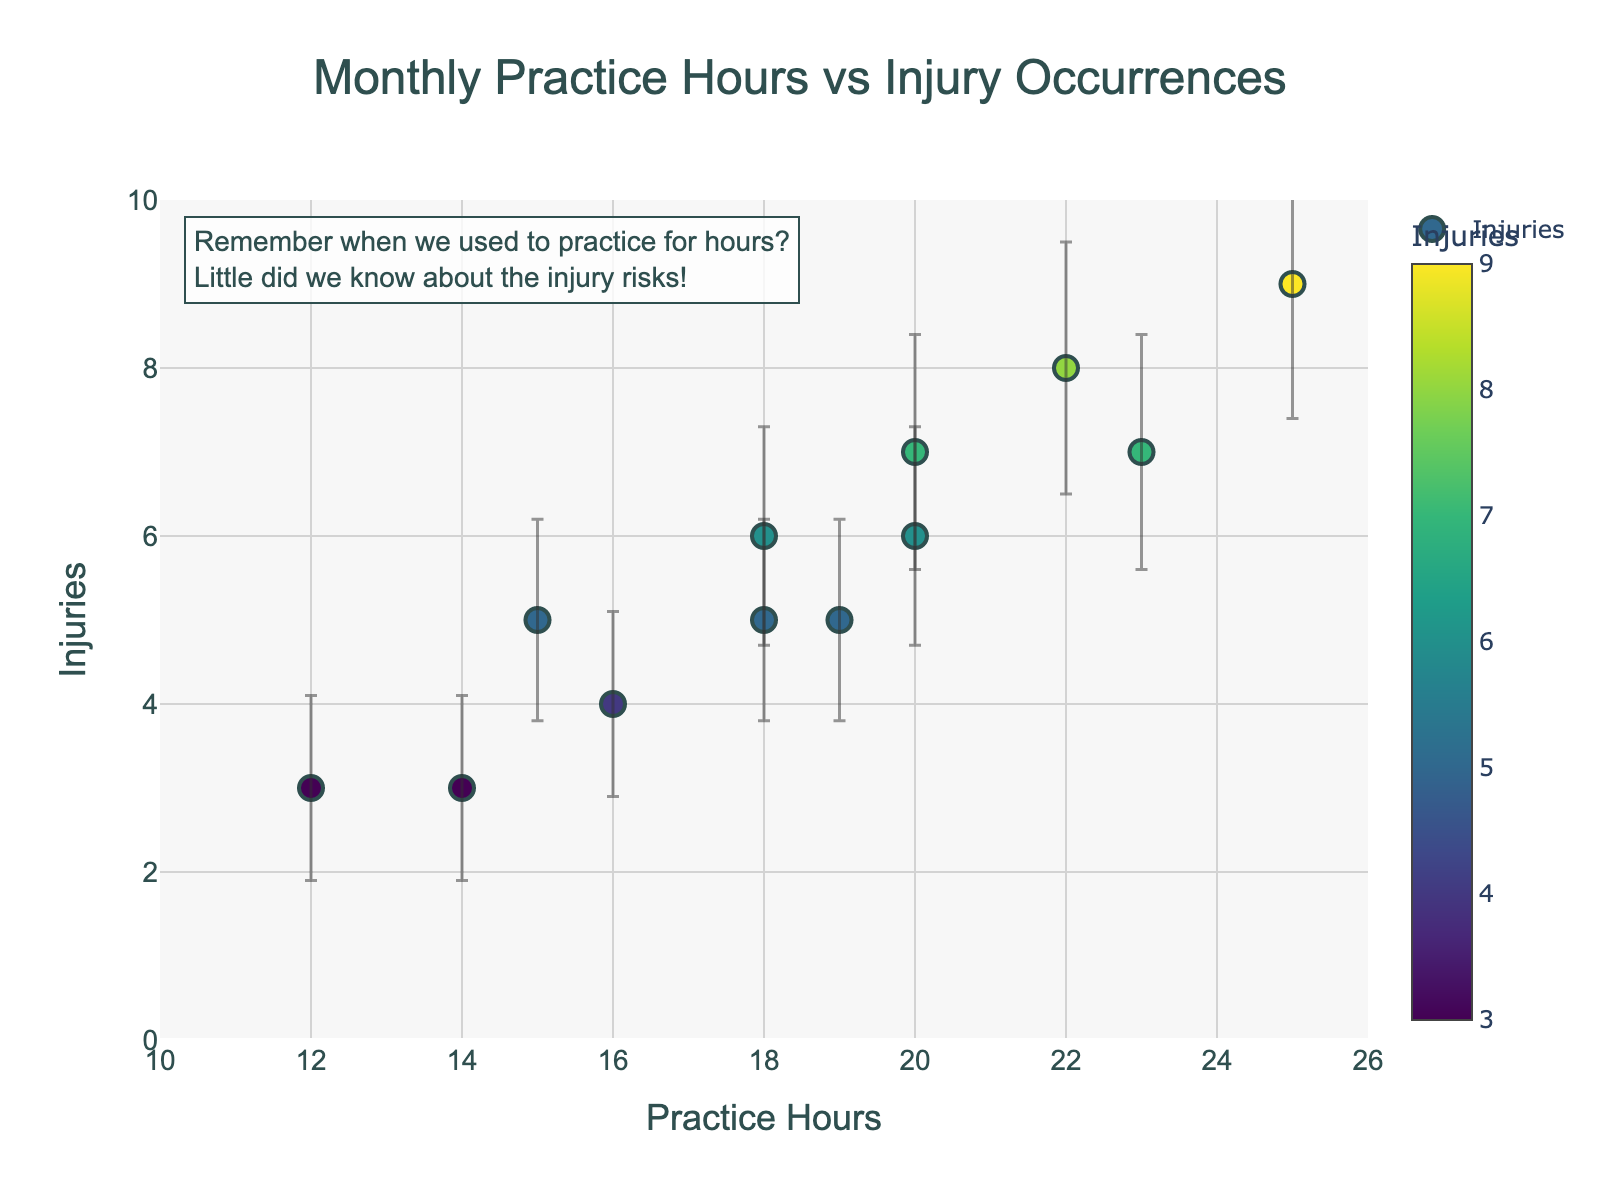What is the title of the plot? The title of the plot is located at the top center and reads "Monthly Practice Hours vs Injury Occurrences".
Answer: Monthly Practice Hours vs Injury Occurrences How many data points are there in the plot? The plot has markers for each month of the year, indicating there are 12 data points.
Answer: 12 Which month had the highest number of injuries? By hovering over the plot, you see that June had the highest number of injuries with 9.
Answer: June What are the ranges for the x-axis and y-axis? The x-axis ranges from 10 to 26 Practice Hours, and the y-axis ranges from 0 to 10 Injuries as observed from the axis labels.
Answer: x: 10 to 26, y: 0 to 10 Which month had the lowest practice hours and how many injuries occurred in that month? By checking the hover information, January and December both had the lowest practice hours of 12 and 14 respectively, January had 5 injuries and December had 3 injuries. So December had the lowest practice hours and caused 3 injuries.
Answer: December, 3 What is the average number of injuries across these months? To find the average, sum up the injuries (5 + 3 + 7 + 6 + 8 + 9 + 7 + 5 + 4 + 6 + 5 + 3 = 68) and divide by the number of months (12). The calculation is 68/12.
Answer: 5.67 In which month did the number of injuries have the highest uncertainty? The error bars represent the uncertainty or variation. The longest error bar is in June, indicating the highest uncertainty in June.
Answer: June Is there a positive correlation between practice hours and injuries? By observing the trend, as practice hours increase, the number of injuries also tends to increase, indicating a positive correlation.
Answer: Yes Which months have the same number of injuries but different practice hours? From the plot, July and March have the same number of injuries (7), but different practice hours of 23 and 20 respectively. October and April have the same number of injuries (6) with practice hours of 20 and 18 respectively.
Answer: July and March, October and April 